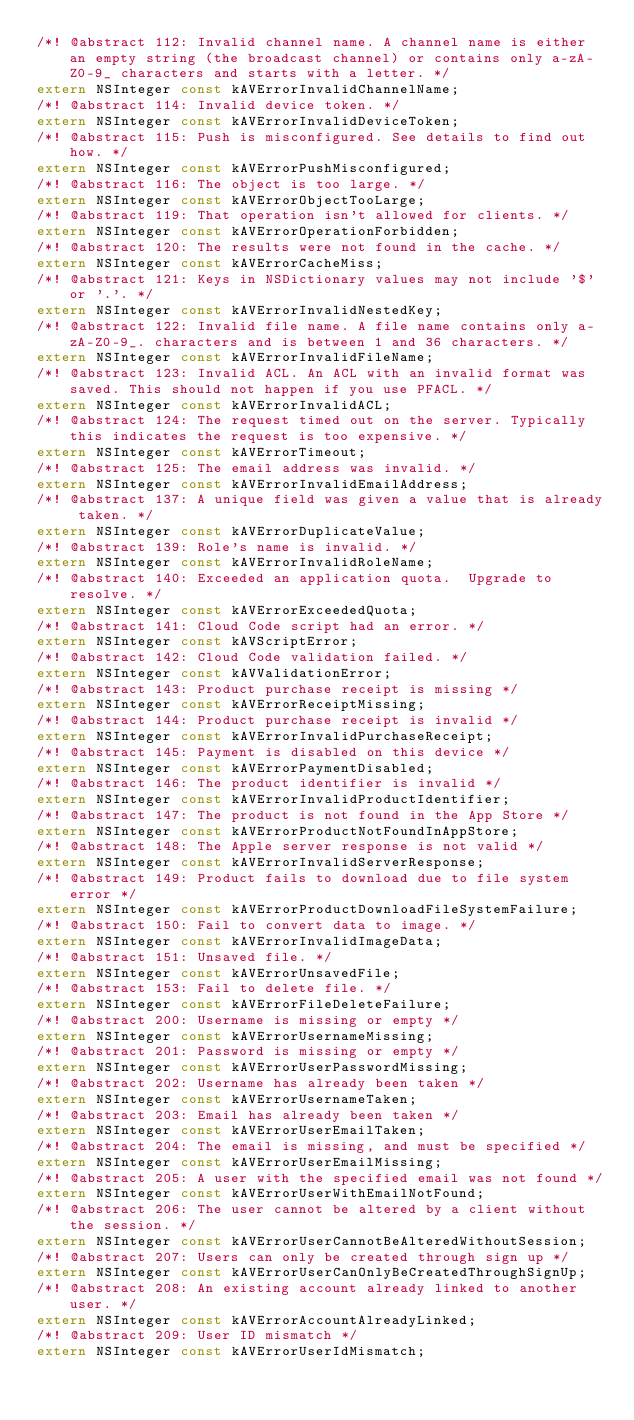<code> <loc_0><loc_0><loc_500><loc_500><_C_>/*! @abstract 112: Invalid channel name. A channel name is either an empty string (the broadcast channel) or contains only a-zA-Z0-9_ characters and starts with a letter. */
extern NSInteger const kAVErrorInvalidChannelName;
/*! @abstract 114: Invalid device token. */
extern NSInteger const kAVErrorInvalidDeviceToken;
/*! @abstract 115: Push is misconfigured. See details to find out how. */
extern NSInteger const kAVErrorPushMisconfigured;
/*! @abstract 116: The object is too large. */
extern NSInteger const kAVErrorObjectTooLarge;
/*! @abstract 119: That operation isn't allowed for clients. */
extern NSInteger const kAVErrorOperationForbidden;
/*! @abstract 120: The results were not found in the cache. */
extern NSInteger const kAVErrorCacheMiss;
/*! @abstract 121: Keys in NSDictionary values may not include '$' or '.'. */
extern NSInteger const kAVErrorInvalidNestedKey;
/*! @abstract 122: Invalid file name. A file name contains only a-zA-Z0-9_. characters and is between 1 and 36 characters. */
extern NSInteger const kAVErrorInvalidFileName;
/*! @abstract 123: Invalid ACL. An ACL with an invalid format was saved. This should not happen if you use PFACL. */
extern NSInteger const kAVErrorInvalidACL;
/*! @abstract 124: The request timed out on the server. Typically this indicates the request is too expensive. */
extern NSInteger const kAVErrorTimeout;
/*! @abstract 125: The email address was invalid. */
extern NSInteger const kAVErrorInvalidEmailAddress;
/*! @abstract 137: A unique field was given a value that is already taken. */
extern NSInteger const kAVErrorDuplicateValue;
/*! @abstract 139: Role's name is invalid. */
extern NSInteger const kAVErrorInvalidRoleName;
/*! @abstract 140: Exceeded an application quota.  Upgrade to resolve. */
extern NSInteger const kAVErrorExceededQuota;
/*! @abstract 141: Cloud Code script had an error. */
extern NSInteger const kAVScriptError;
/*! @abstract 142: Cloud Code validation failed. */
extern NSInteger const kAVValidationError;
/*! @abstract 143: Product purchase receipt is missing */
extern NSInteger const kAVErrorReceiptMissing;
/*! @abstract 144: Product purchase receipt is invalid */
extern NSInteger const kAVErrorInvalidPurchaseReceipt;
/*! @abstract 145: Payment is disabled on this device */
extern NSInteger const kAVErrorPaymentDisabled;
/*! @abstract 146: The product identifier is invalid */
extern NSInteger const kAVErrorInvalidProductIdentifier;
/*! @abstract 147: The product is not found in the App Store */
extern NSInteger const kAVErrorProductNotFoundInAppStore;
/*! @abstract 148: The Apple server response is not valid */
extern NSInteger const kAVErrorInvalidServerResponse;
/*! @abstract 149: Product fails to download due to file system error */
extern NSInteger const kAVErrorProductDownloadFileSystemFailure;
/*! @abstract 150: Fail to convert data to image. */
extern NSInteger const kAVErrorInvalidImageData;
/*! @abstract 151: Unsaved file. */
extern NSInteger const kAVErrorUnsavedFile;
/*! @abstract 153: Fail to delete file. */
extern NSInteger const kAVErrorFileDeleteFailure;
/*! @abstract 200: Username is missing or empty */
extern NSInteger const kAVErrorUsernameMissing;
/*! @abstract 201: Password is missing or empty */
extern NSInteger const kAVErrorUserPasswordMissing;
/*! @abstract 202: Username has already been taken */
extern NSInteger const kAVErrorUsernameTaken;
/*! @abstract 203: Email has already been taken */
extern NSInteger const kAVErrorUserEmailTaken;
/*! @abstract 204: The email is missing, and must be specified */
extern NSInteger const kAVErrorUserEmailMissing;
/*! @abstract 205: A user with the specified email was not found */
extern NSInteger const kAVErrorUserWithEmailNotFound;
/*! @abstract 206: The user cannot be altered by a client without the session. */
extern NSInteger const kAVErrorUserCannotBeAlteredWithoutSession;
/*! @abstract 207: Users can only be created through sign up */
extern NSInteger const kAVErrorUserCanOnlyBeCreatedThroughSignUp;
/*! @abstract 208: An existing account already linked to another user. */
extern NSInteger const kAVErrorAccountAlreadyLinked;
/*! @abstract 209: User ID mismatch */
extern NSInteger const kAVErrorUserIdMismatch;</code> 